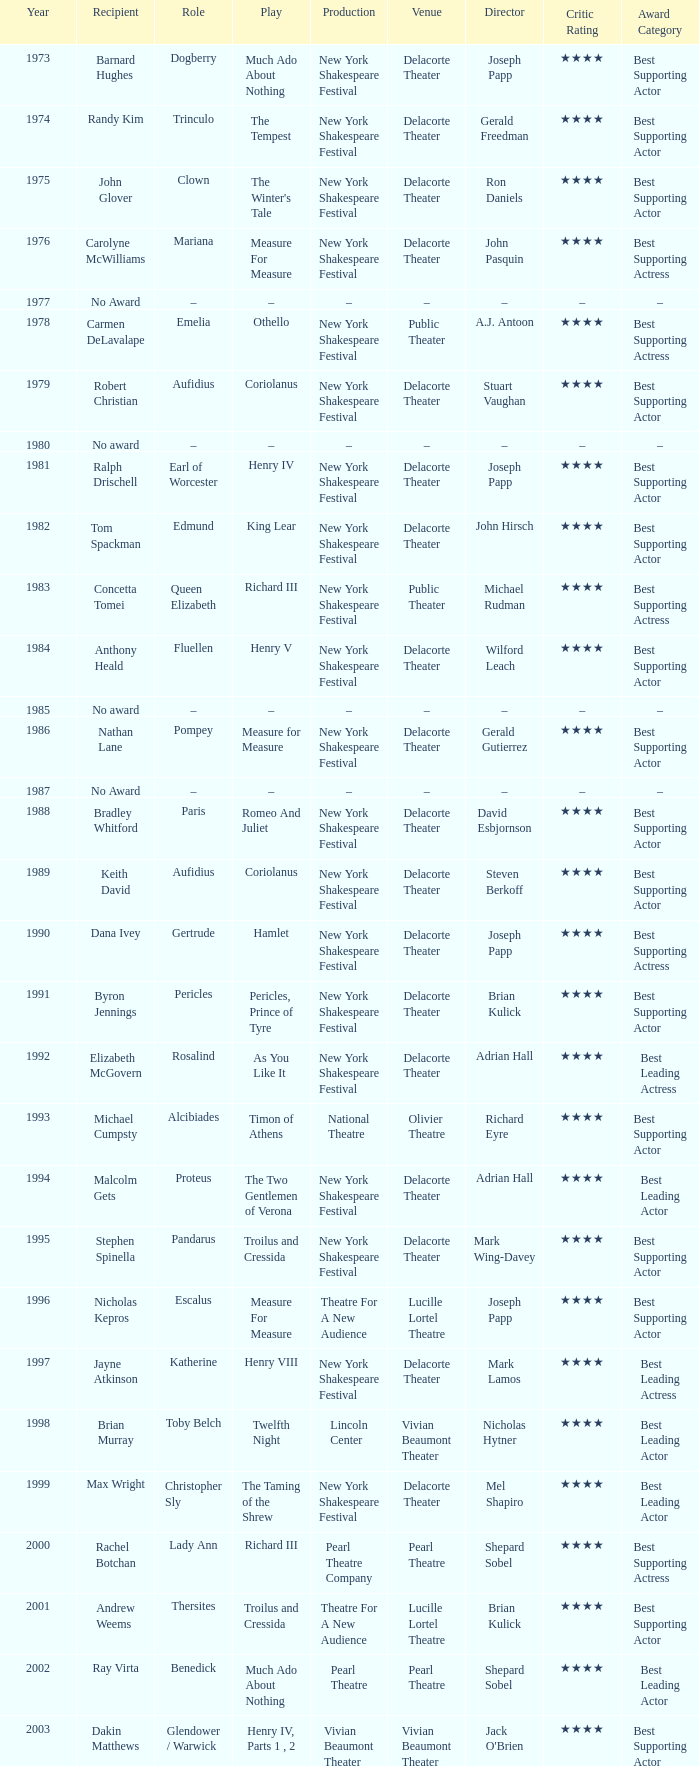Name the play for 1976 Measure For Measure. 